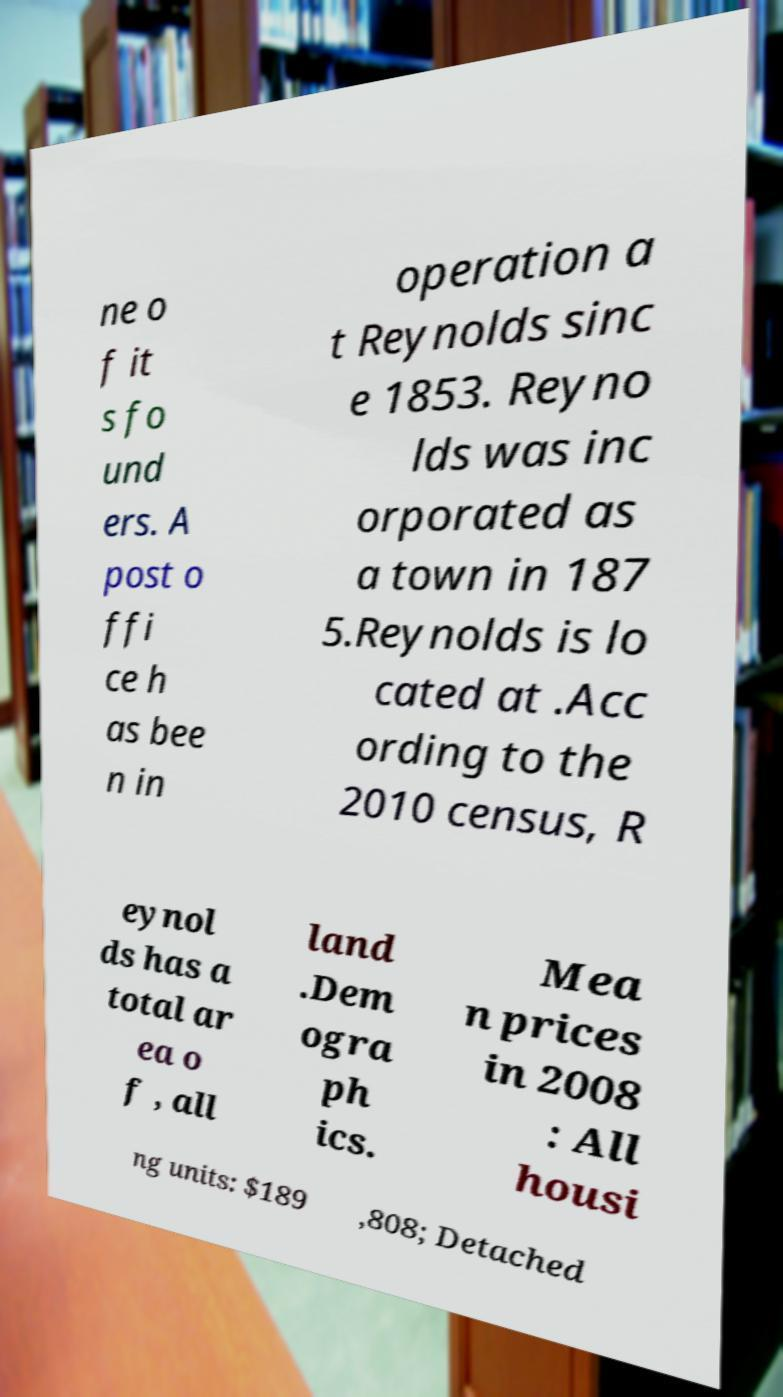There's text embedded in this image that I need extracted. Can you transcribe it verbatim? ne o f it s fo und ers. A post o ffi ce h as bee n in operation a t Reynolds sinc e 1853. Reyno lds was inc orporated as a town in 187 5.Reynolds is lo cated at .Acc ording to the 2010 census, R eynol ds has a total ar ea o f , all land .Dem ogra ph ics. Mea n prices in 2008 : All housi ng units: $189 ,808; Detached 